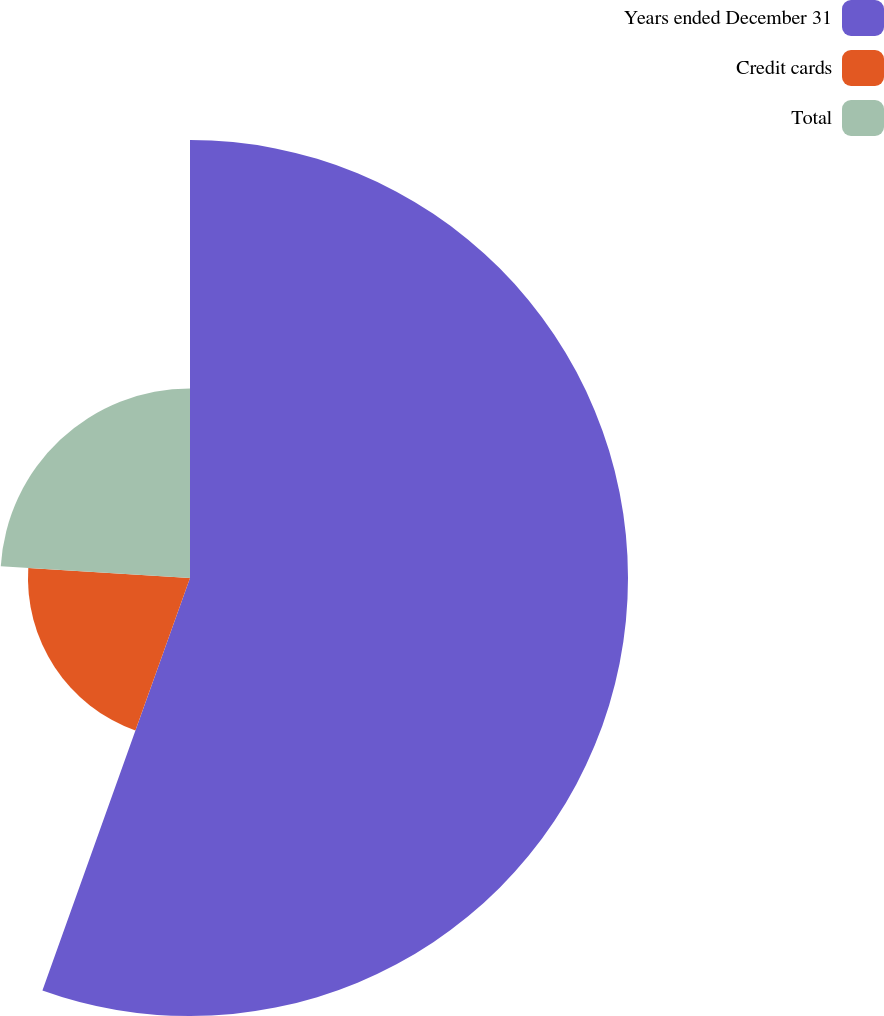Convert chart to OTSL. <chart><loc_0><loc_0><loc_500><loc_500><pie_chart><fcel>Years ended December 31<fcel>Credit cards<fcel>Total<nl><fcel>55.47%<fcel>20.52%<fcel>24.01%<nl></chart> 